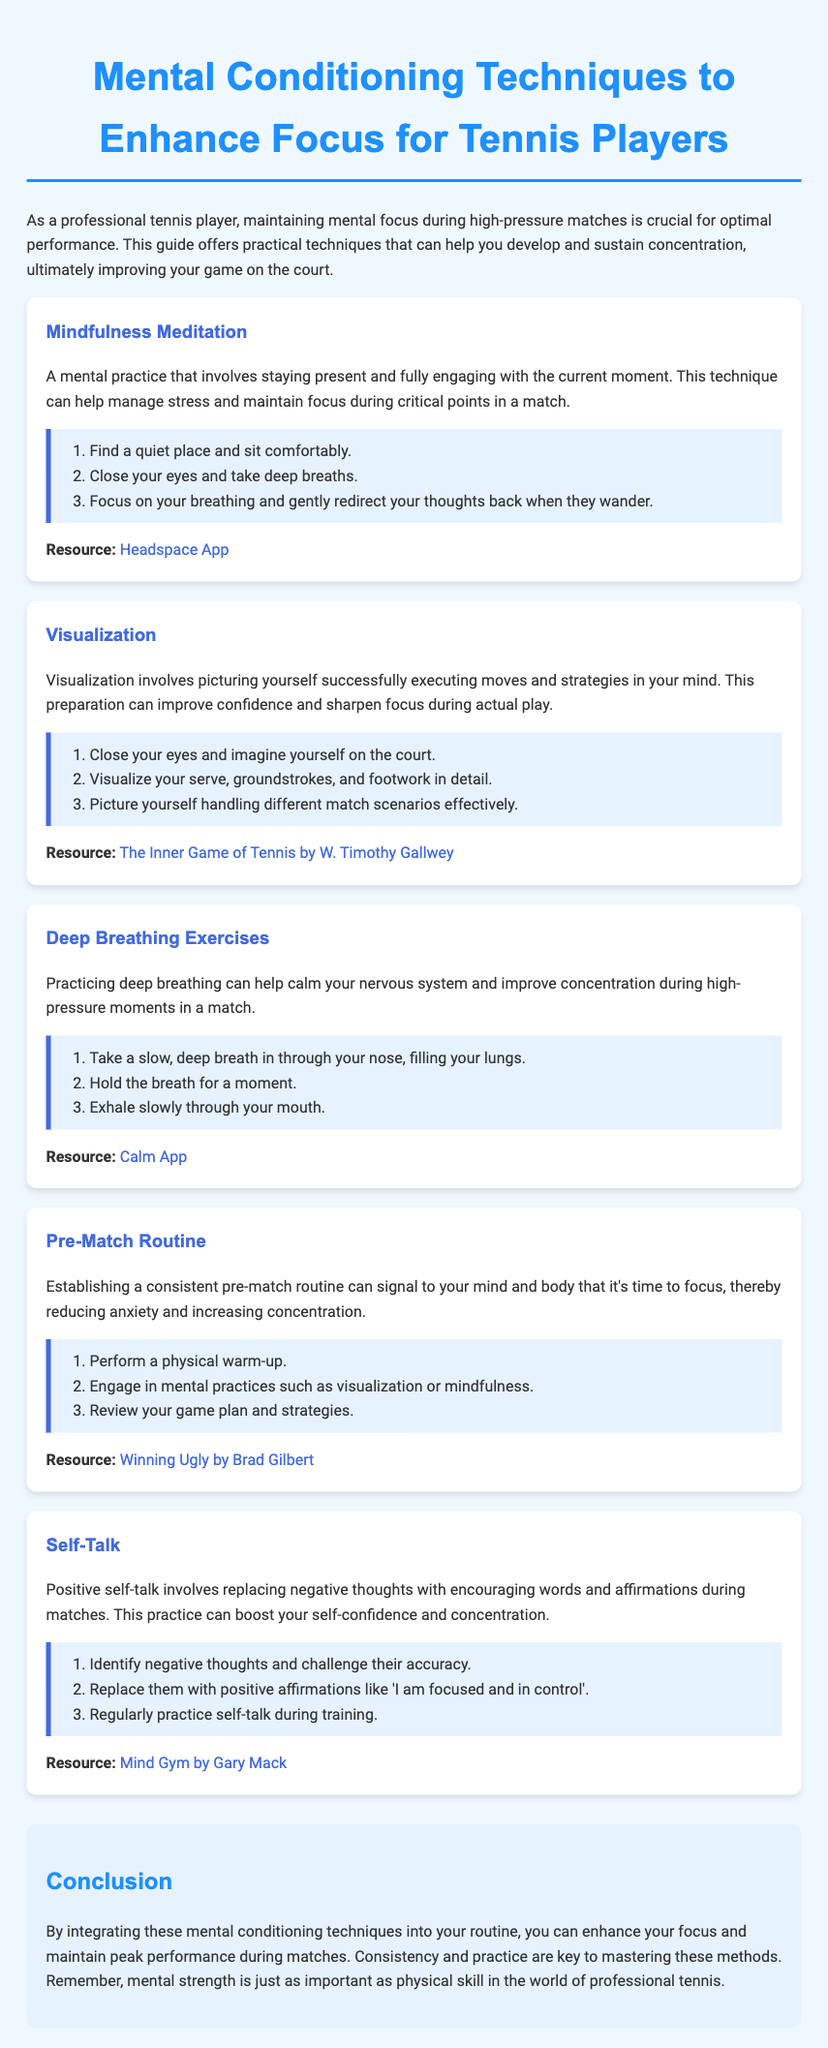What is the title of the guide? The title of the guide is presented at the top of the document in a prominent header.
Answer: Mental Conditioning Techniques to Enhance Focus for Tennis Players What technique involves picturing successful execution of moves? The technique described involves visualization and is specifically related to mental conditioning for tennis players.
Answer: Visualization How many steps are provided for mindfulness meditation? The steps for mindfulness meditation are listed in an ordered list format, making it easy to count them.
Answer: 3 What resource is recommended for mindfulness meditation? The specific resource linked in the mindfulness meditation section is identified as a helpful tool.
Answer: Headspace App What practice helps calm the nervous system? The technique focused on calming the nervous system is clearly stated in the deep breathing exercises section.
Answer: Deep Breathing Exercises What is the main purpose of a pre-match routine? The purpose of establishing a pre-match routine is clearly mentioned in the document's explanation of its benefits.
Answer: To signal focus and reduce anxiety What kind of thoughts should be challenged during self-talk? The document specifies that negative thoughts should be identified and challenged as part of the self-talk technique.
Answer: Negative thoughts How many techniques are discussed in the document? Each technique is mentioned in distinct sections, which can be tallied for an accurate count.
Answer: 5 